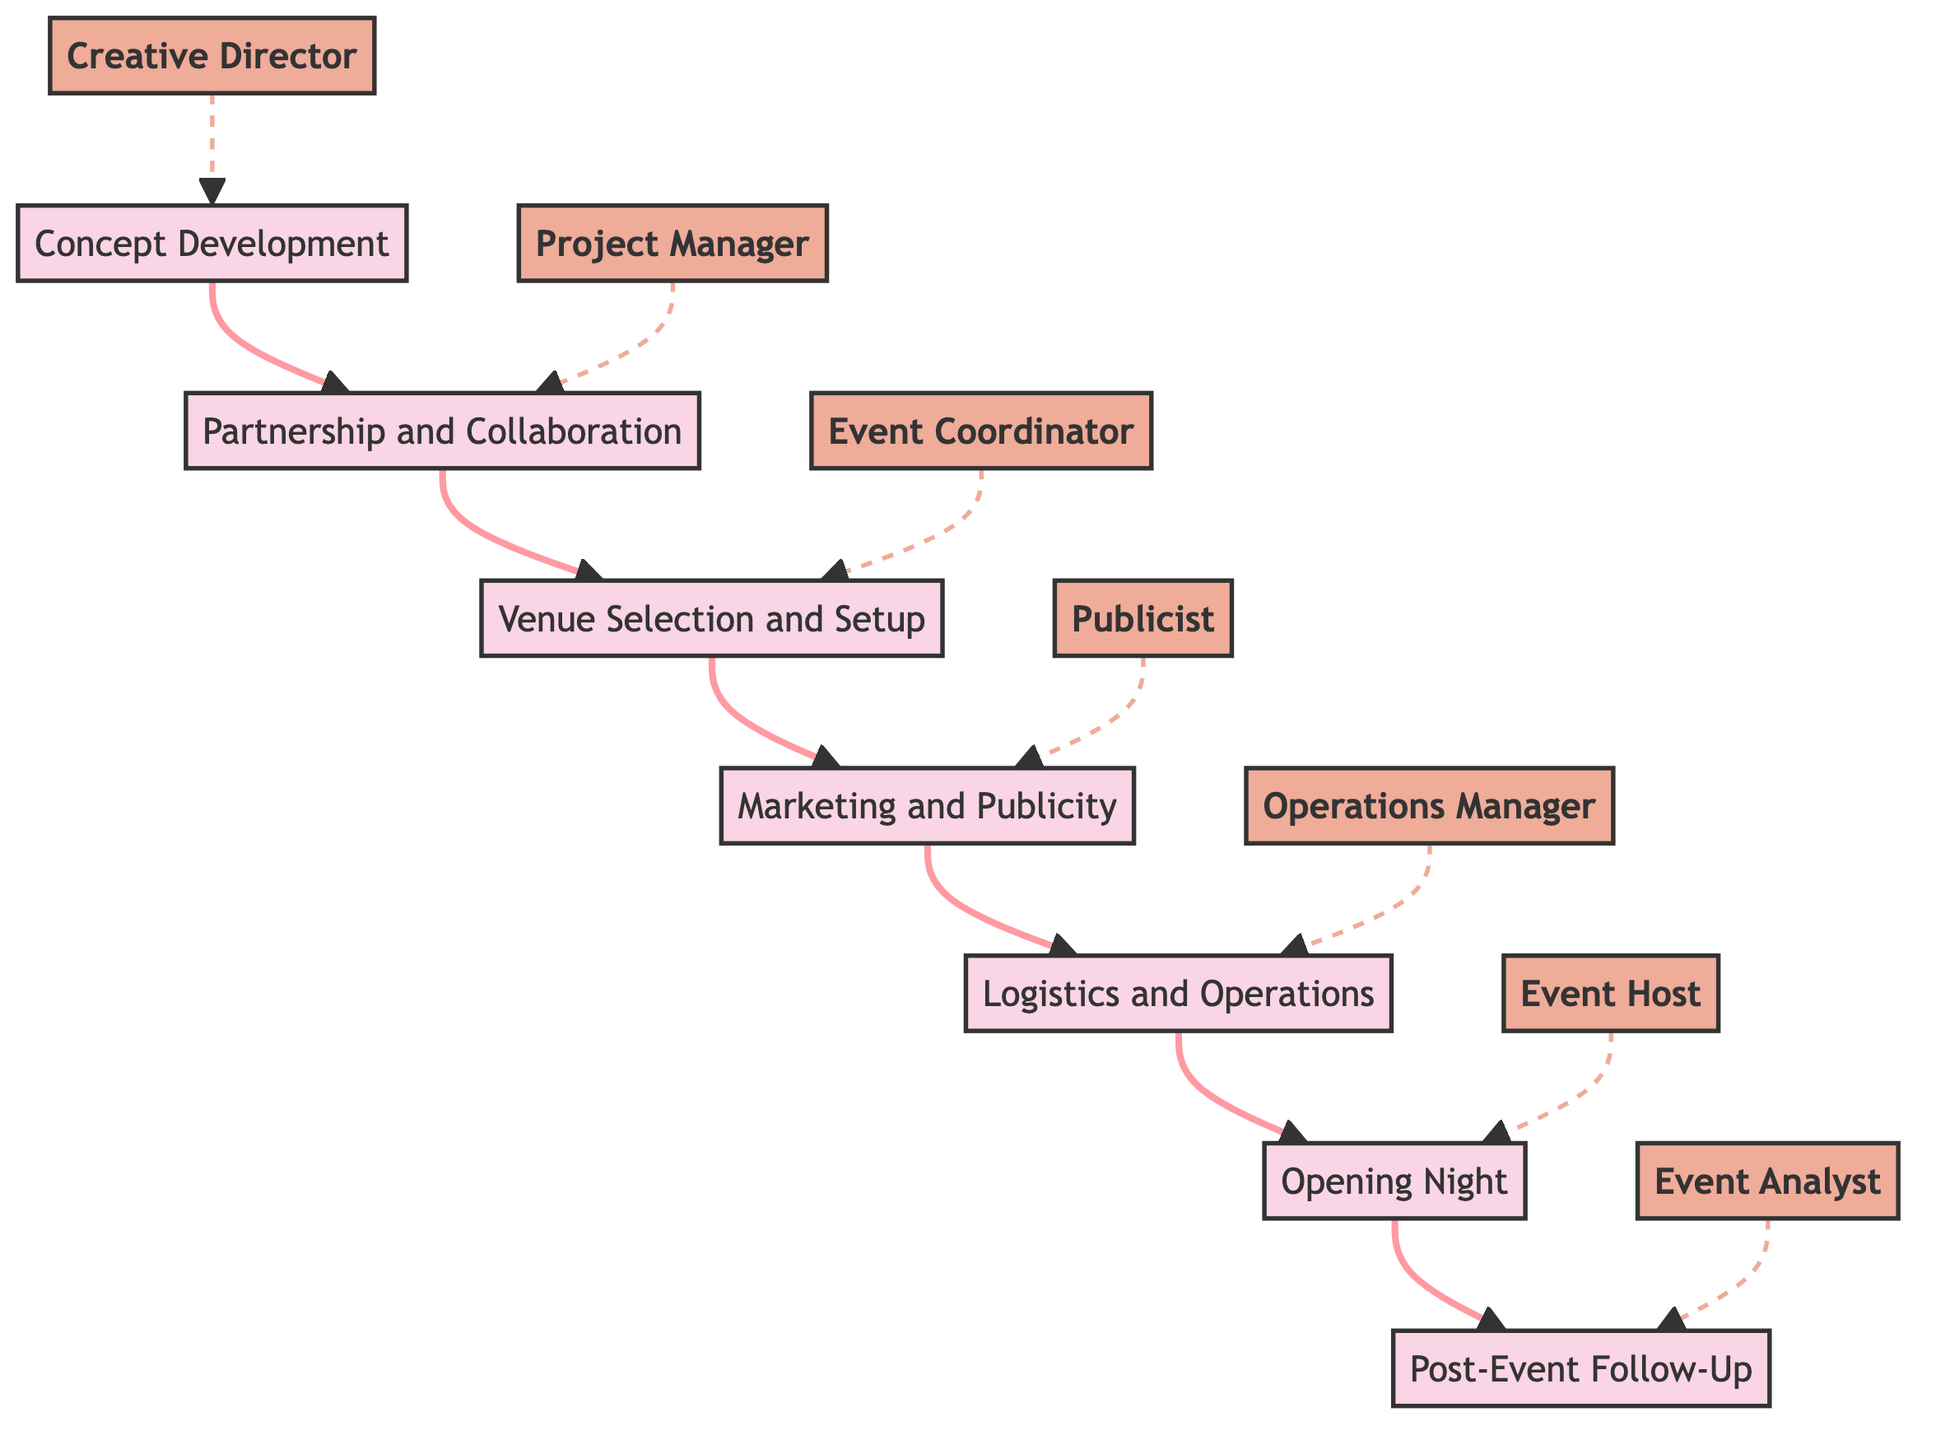What is the first step in the process? According to the diagram, the first step is "Concept Development," as it is the starting node from which all other steps branch off.
Answer: Concept Development Who is in charge of the "Marketing and Publicity" step? The diagram indicates that "Marketing and Publicity" is managed by the person labeled as the "Publicist." This information can be found at the relevant node connected to the "Marketing and Publicity" step.
Answer: Publicist How many total steps are involved in this process? By counting the nodes in the diagram, there are a total of seven distinct steps, represented as nodes from "Concept Development" to "Post-Event Follow-Up."
Answer: Seven Which position is connected to "Opening Night"? The diagram shows that the person responsible for "Opening Night" is the "Event Host," indicating their specific role in this phase of the process.
Answer: Event Host What is the relationship between "Partnership and Collaboration" and "Venue Selection and Setup"? "Partnership and Collaboration" leads directly to "Venue Selection and Setup," showing that after securing collaborations, the next step is to choose a venue for the exhibition.
Answer: Directly leads to Who follows "Event Coordinator" in the sequence of steps? In the sequence of steps outlined in the diagram, the "Event Coordinator" is followed by the "Publicist," indicating the next step in the process after venue selection.
Answer: Publicist What is the last step in this series of tasks? The final step in the diagram is "Post-Event Follow-Up," which indicates the last phase after the main events have taken place and evaluations are being conducted.
Answer: Post-Event Follow-Up What type of diagram is represented here? The diagram is a "Block Diagram," which is specifically used to illustrate the sequence of steps and the roles involved in preparing for an art exhibition and film premier.
Answer: Block Diagram How is the "Logistics and Operations" step visually connected to the rest of the process? In the diagram, the "Logistics and Operations" step is connected by a directed edge to "Opening Night," signifying that logistical planning is essential for the successful execution of the opening event.
Answer: Connected by directed edge 